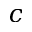<formula> <loc_0><loc_0><loc_500><loc_500>c</formula> 